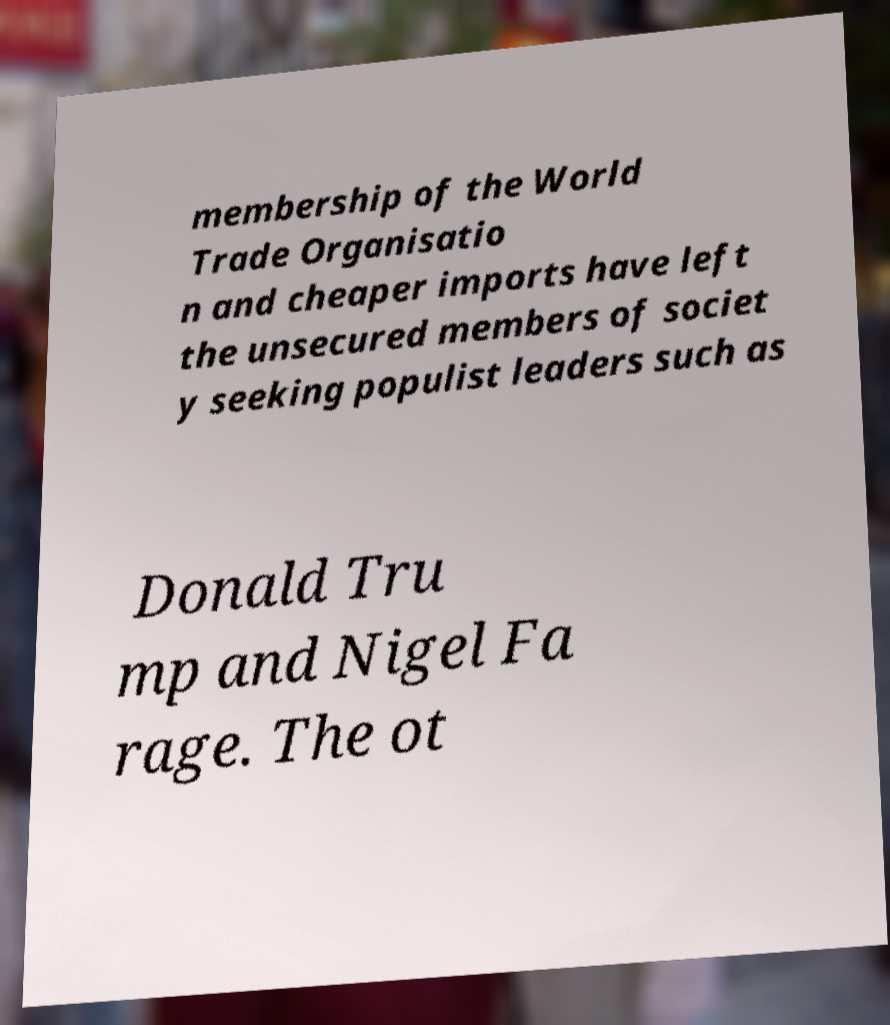For documentation purposes, I need the text within this image transcribed. Could you provide that? membership of the World Trade Organisatio n and cheaper imports have left the unsecured members of societ y seeking populist leaders such as Donald Tru mp and Nigel Fa rage. The ot 